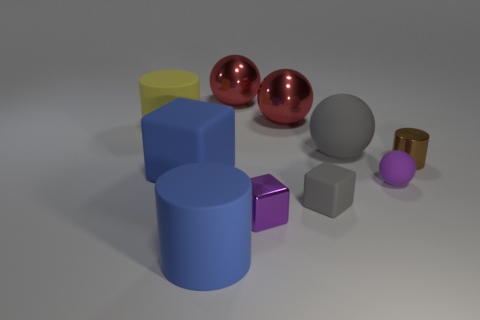Subtract all gray balls. How many balls are left? 3 Subtract 1 cylinders. How many cylinders are left? 2 Subtract all tiny rubber balls. How many balls are left? 3 Subtract all yellow spheres. Subtract all green cylinders. How many spheres are left? 4 Subtract all spheres. How many objects are left? 6 Subtract 0 brown cubes. How many objects are left? 10 Subtract all big blue objects. Subtract all large gray spheres. How many objects are left? 7 Add 8 big red metallic balls. How many big red metallic balls are left? 10 Add 3 purple rubber balls. How many purple rubber balls exist? 4 